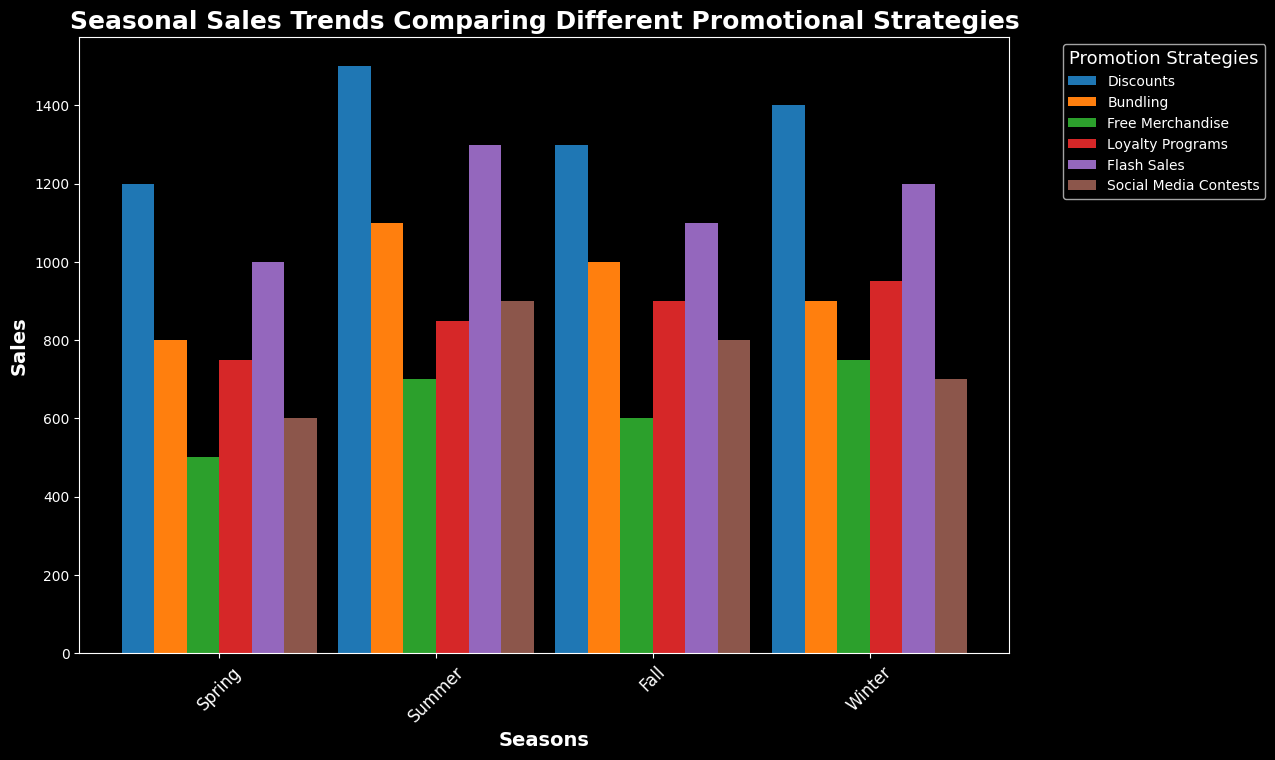Which promotion strategy has the highest sales in Summer? Looking at the bar corresponding to Summer, the highest bar is for the "Discounts" strategy.
Answer: Discounts How do the sales from Flash Sales in Winter compare to those in Summer? In Winter, Flash Sales have sales of 1200, while in Summer, they have sales of 1300. 1300 is greater than 1200.
Answer: Sales in Summer are higher Which season has the lowest sales for Social Media Contests? Observing the bars for Social Media Contests across the seasons, the shortest bar is in Winter.
Answer: Winter What's the difference in sales between Discounts and Bundling in Fall? The sales for Discounts in Fall are 1300 and for Bundling are 1000. The difference is 1300 - 1000.
Answer: 300 What is the total sales for Bundling across all seasons? Summing the sales for Bundling across Spring, Summer, Fall, and Winter: 800 + 1100 + 1000 + 900 = 3800.
Answer: 3800 Which promotion strategy shows the least fluctuation in sales across all seasons? Comparing the bars for each strategy, Loyalty Programs has a relatively stable sales pattern: 750, 850, 900, 950.
Answer: Loyalty Programs How much more in sales did Discounts generate in Spring compared to Free Merchandise in the same season? Sales for Discounts in Spring are 1200, and for Free Merchandise, it is 500. The difference is 1200 - 500.
Answer: 700 What is the average sales for Flash Sales across the four seasons? The sales for Flash Sales in Spring, Summer, Fall, and Winter are 1000, 1300, 1100, and 1200 respectively. The average is (1000 + 1300 + 1100 + 1200) / 4.
Answer: 1150 Which two promotional strategies have the closest sales in Fall? Observing the bars in the Fall season, Flash Sales and Loyalty Programs have similar heights, with sales of 1100 and 900 respectively, making a difference of 200.
Answer: Flash Sales and Loyalty Programs During which season does Free Merchandise see the highest sales? Observing the bars for Free Merchandise across the seasons, the highest bar is in Winter.
Answer: Winter 